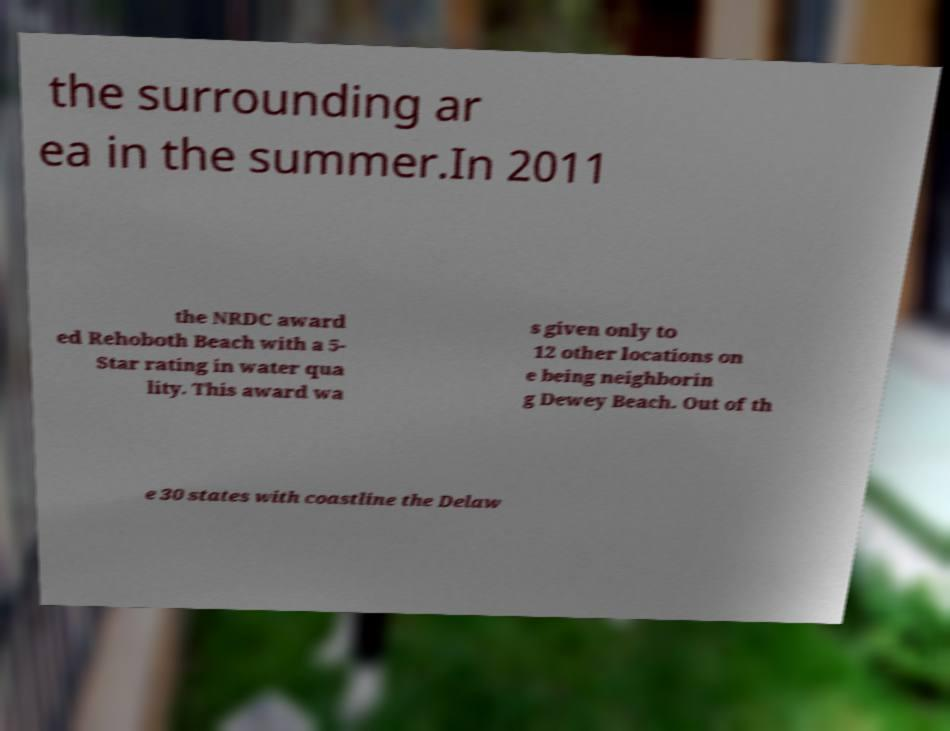I need the written content from this picture converted into text. Can you do that? the surrounding ar ea in the summer.In 2011 the NRDC award ed Rehoboth Beach with a 5- Star rating in water qua lity. This award wa s given only to 12 other locations on e being neighborin g Dewey Beach. Out of th e 30 states with coastline the Delaw 